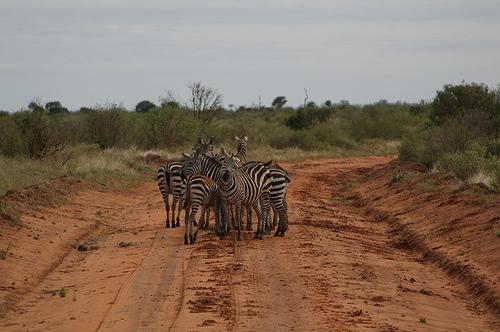Are the zebras standing on grass?
Answer briefly. No. Are the zebras in their natural habitat?
Keep it brief. Yes. How many type of animals are blocking the dirt road?
Quick response, please. 1. How many zebras can you count?
Answer briefly. 5. 